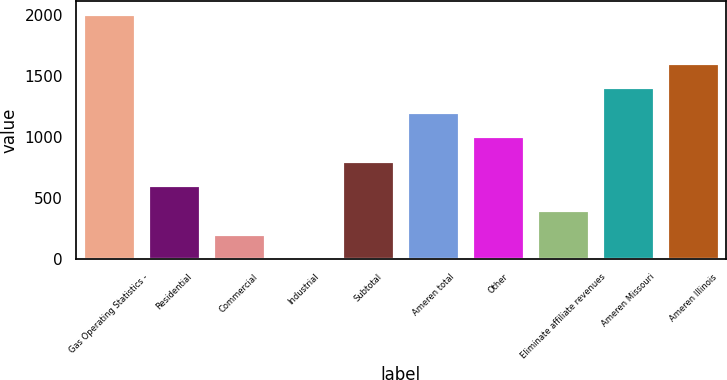Convert chart. <chart><loc_0><loc_0><loc_500><loc_500><bar_chart><fcel>Gas Operating Statistics -<fcel>Residential<fcel>Commercial<fcel>Industrial<fcel>Subtotal<fcel>Ameren total<fcel>Other<fcel>Eliminate affiliate revenues<fcel>Ameren Missouri<fcel>Ameren Illinois<nl><fcel>2010<fcel>603.7<fcel>201.9<fcel>1<fcel>804.6<fcel>1206.4<fcel>1005.5<fcel>402.8<fcel>1407.3<fcel>1608.2<nl></chart> 